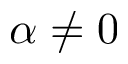Convert formula to latex. <formula><loc_0><loc_0><loc_500><loc_500>\alpha \neq 0</formula> 